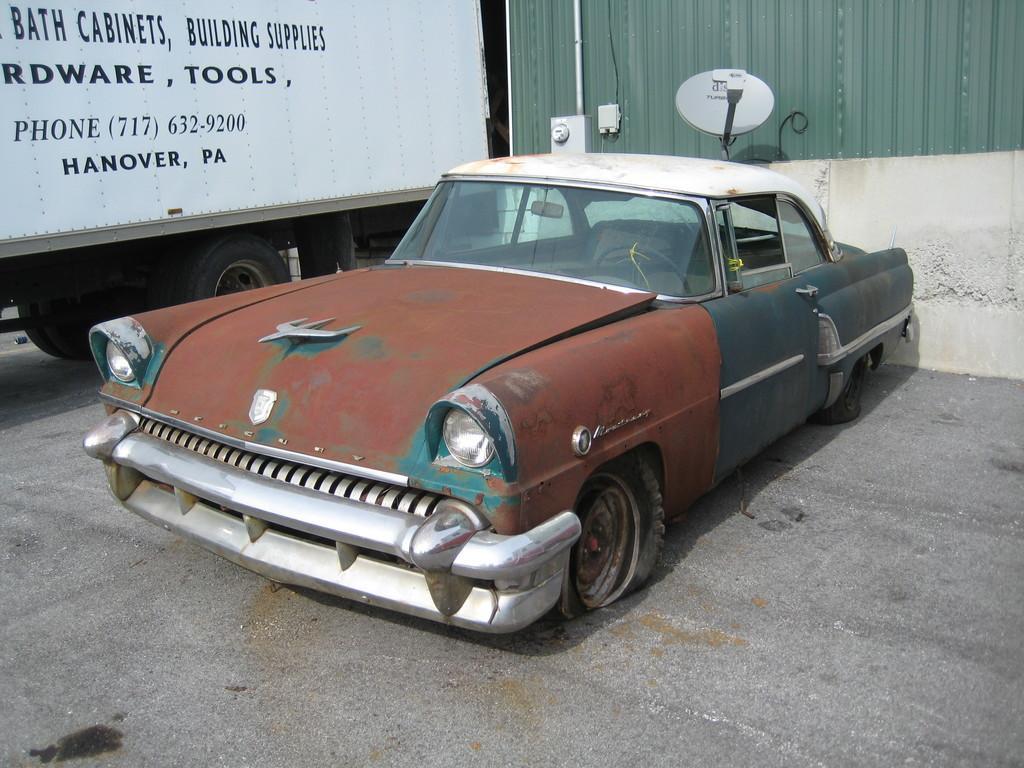Describe this image in one or two sentences. In the picture we can see an old vintage car beside to it, we can see a truck with a white color box on it and in the background we can see a wall with a dish. 